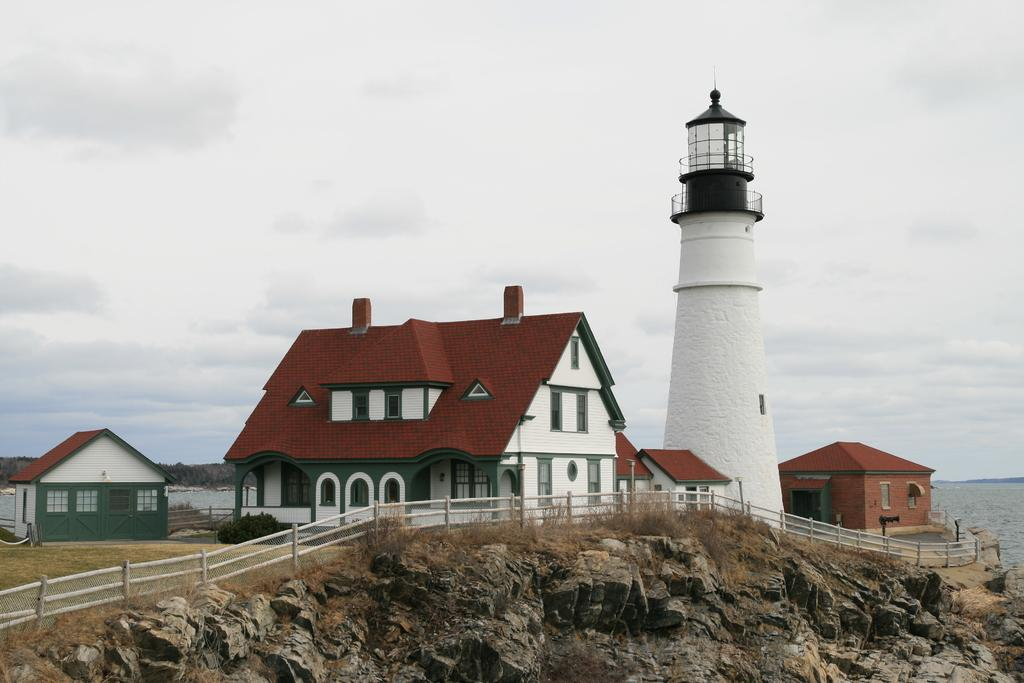What type of structures can be seen in the image? There are houses in the image. What is the purpose of the fence in the image? The fence in the image serves as a boundary or barrier. What type of vegetation is present in the image? There are plants in the image. What is the tall structure on the hill in the image? There is a lighthouse on a hill in the image. What can be seen on the right side of the image? There is water on the right side of the image. What is visible in the background of the image? The sky is visible in the background of the image. What type of wool is being spun by the pen on the curve in the image? There is no wool or pen present in the image, and no curve is mentioned in the provided facts. 